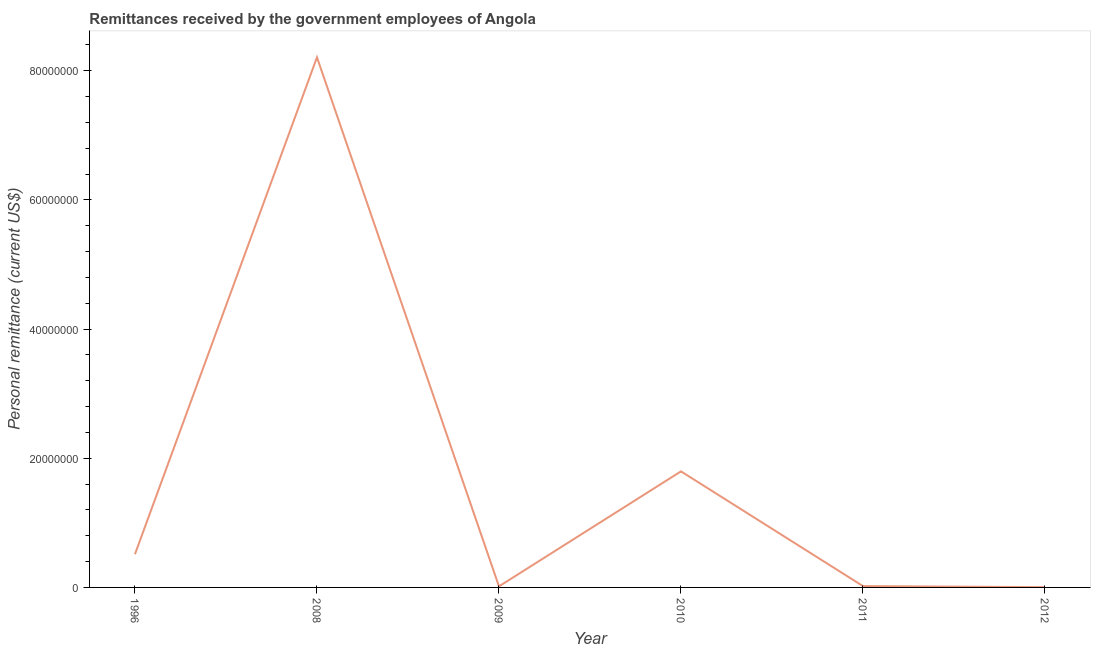What is the personal remittances in 2010?
Offer a very short reply. 1.80e+07. Across all years, what is the maximum personal remittances?
Make the answer very short. 8.21e+07. Across all years, what is the minimum personal remittances?
Your response must be concise. 4.50e+04. In which year was the personal remittances maximum?
Ensure brevity in your answer.  2008. In which year was the personal remittances minimum?
Offer a very short reply. 2012. What is the sum of the personal remittances?
Your answer should be compact. 1.06e+08. What is the difference between the personal remittances in 2010 and 2011?
Provide a succinct answer. 1.78e+07. What is the average personal remittances per year?
Your response must be concise. 1.76e+07. What is the median personal remittances?
Keep it short and to the point. 2.67e+06. In how many years, is the personal remittances greater than 68000000 US$?
Provide a short and direct response. 1. What is the ratio of the personal remittances in 1996 to that in 2010?
Your response must be concise. 0.29. What is the difference between the highest and the second highest personal remittances?
Give a very brief answer. 6.41e+07. Is the sum of the personal remittances in 1996 and 2012 greater than the maximum personal remittances across all years?
Provide a succinct answer. No. What is the difference between the highest and the lowest personal remittances?
Make the answer very short. 8.20e+07. In how many years, is the personal remittances greater than the average personal remittances taken over all years?
Provide a short and direct response. 2. Does the personal remittances monotonically increase over the years?
Your response must be concise. No. How many lines are there?
Keep it short and to the point. 1. How many years are there in the graph?
Offer a very short reply. 6. What is the difference between two consecutive major ticks on the Y-axis?
Your answer should be very brief. 2.00e+07. Are the values on the major ticks of Y-axis written in scientific E-notation?
Ensure brevity in your answer.  No. Does the graph contain any zero values?
Ensure brevity in your answer.  No. Does the graph contain grids?
Your response must be concise. No. What is the title of the graph?
Make the answer very short. Remittances received by the government employees of Angola. What is the label or title of the X-axis?
Offer a very short reply. Year. What is the label or title of the Y-axis?
Offer a very short reply. Personal remittance (current US$). What is the Personal remittance (current US$) of 1996?
Make the answer very short. 5.14e+06. What is the Personal remittance (current US$) in 2008?
Your answer should be compact. 8.21e+07. What is the Personal remittance (current US$) of 2009?
Make the answer very short. 1.62e+05. What is the Personal remittance (current US$) of 2010?
Make the answer very short. 1.80e+07. What is the Personal remittance (current US$) of 2011?
Keep it short and to the point. 2.05e+05. What is the Personal remittance (current US$) of 2012?
Provide a short and direct response. 4.50e+04. What is the difference between the Personal remittance (current US$) in 1996 and 2008?
Provide a short and direct response. -7.69e+07. What is the difference between the Personal remittance (current US$) in 1996 and 2009?
Make the answer very short. 4.98e+06. What is the difference between the Personal remittance (current US$) in 1996 and 2010?
Provide a succinct answer. -1.28e+07. What is the difference between the Personal remittance (current US$) in 1996 and 2011?
Your response must be concise. 4.94e+06. What is the difference between the Personal remittance (current US$) in 1996 and 2012?
Keep it short and to the point. 5.10e+06. What is the difference between the Personal remittance (current US$) in 2008 and 2009?
Your answer should be very brief. 8.19e+07. What is the difference between the Personal remittance (current US$) in 2008 and 2010?
Make the answer very short. 6.41e+07. What is the difference between the Personal remittance (current US$) in 2008 and 2011?
Your response must be concise. 8.19e+07. What is the difference between the Personal remittance (current US$) in 2008 and 2012?
Offer a very short reply. 8.20e+07. What is the difference between the Personal remittance (current US$) in 2009 and 2010?
Your answer should be compact. -1.78e+07. What is the difference between the Personal remittance (current US$) in 2009 and 2011?
Provide a succinct answer. -4.24e+04. What is the difference between the Personal remittance (current US$) in 2009 and 2012?
Keep it short and to the point. 1.17e+05. What is the difference between the Personal remittance (current US$) in 2010 and 2011?
Ensure brevity in your answer.  1.78e+07. What is the difference between the Personal remittance (current US$) in 2010 and 2012?
Ensure brevity in your answer.  1.79e+07. What is the difference between the Personal remittance (current US$) in 2011 and 2012?
Your response must be concise. 1.60e+05. What is the ratio of the Personal remittance (current US$) in 1996 to that in 2008?
Your response must be concise. 0.06. What is the ratio of the Personal remittance (current US$) in 1996 to that in 2009?
Offer a very short reply. 31.67. What is the ratio of the Personal remittance (current US$) in 1996 to that in 2010?
Provide a succinct answer. 0.29. What is the ratio of the Personal remittance (current US$) in 1996 to that in 2011?
Keep it short and to the point. 25.11. What is the ratio of the Personal remittance (current US$) in 1996 to that in 2012?
Provide a short and direct response. 114.27. What is the ratio of the Personal remittance (current US$) in 2008 to that in 2009?
Your answer should be compact. 505.57. What is the ratio of the Personal remittance (current US$) in 2008 to that in 2010?
Keep it short and to the point. 4.57. What is the ratio of the Personal remittance (current US$) in 2008 to that in 2011?
Your response must be concise. 400.9. What is the ratio of the Personal remittance (current US$) in 2008 to that in 2012?
Offer a very short reply. 1824.09. What is the ratio of the Personal remittance (current US$) in 2009 to that in 2010?
Ensure brevity in your answer.  0.01. What is the ratio of the Personal remittance (current US$) in 2009 to that in 2011?
Your response must be concise. 0.79. What is the ratio of the Personal remittance (current US$) in 2009 to that in 2012?
Your answer should be very brief. 3.61. What is the ratio of the Personal remittance (current US$) in 2010 to that in 2011?
Provide a succinct answer. 87.78. What is the ratio of the Personal remittance (current US$) in 2010 to that in 2012?
Provide a short and direct response. 399.38. What is the ratio of the Personal remittance (current US$) in 2011 to that in 2012?
Your response must be concise. 4.55. 